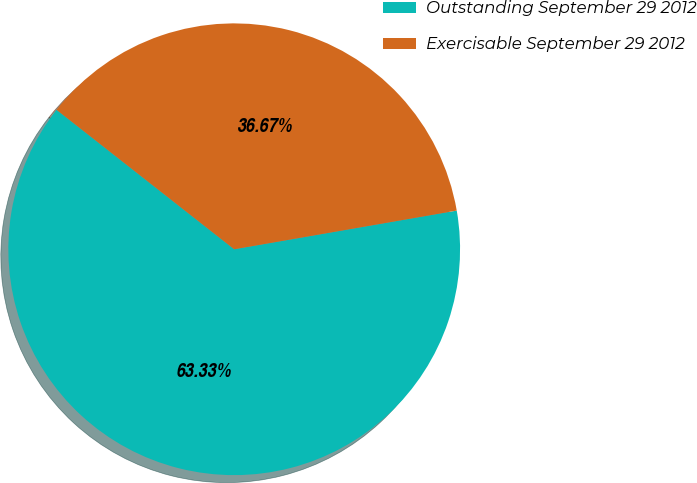Convert chart. <chart><loc_0><loc_0><loc_500><loc_500><pie_chart><fcel>Outstanding September 29 2012<fcel>Exercisable September 29 2012<nl><fcel>63.33%<fcel>36.67%<nl></chart> 